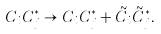<formula> <loc_0><loc_0><loc_500><loc_500>C _ { i } C _ { j } ^ { * } \to C _ { i } C _ { j } ^ { * } + \tilde { C } _ { i } \tilde { C } _ { j } ^ { * } .</formula> 